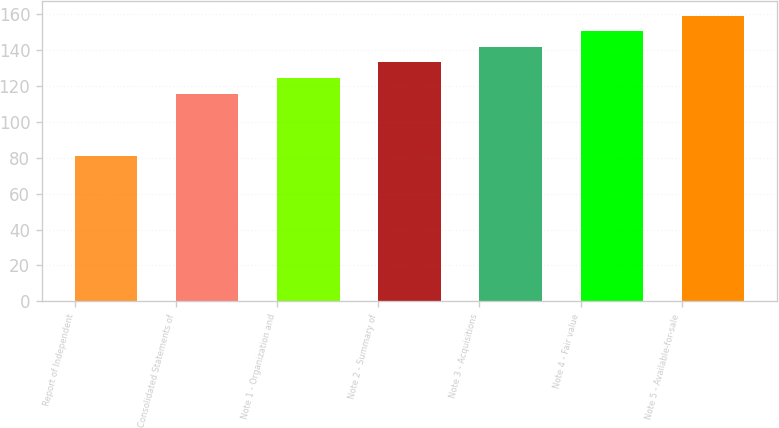Convert chart to OTSL. <chart><loc_0><loc_0><loc_500><loc_500><bar_chart><fcel>Report of Independent<fcel>Consolidated Statements of<fcel>Note 1 - Organization and<fcel>Note 2 - Summary of<fcel>Note 3 - Acquisitions<fcel>Note 4 - Fair value<fcel>Note 5 - Available-for-sale<nl><fcel>81<fcel>115.8<fcel>124.5<fcel>133.2<fcel>141.9<fcel>150.6<fcel>159.3<nl></chart> 